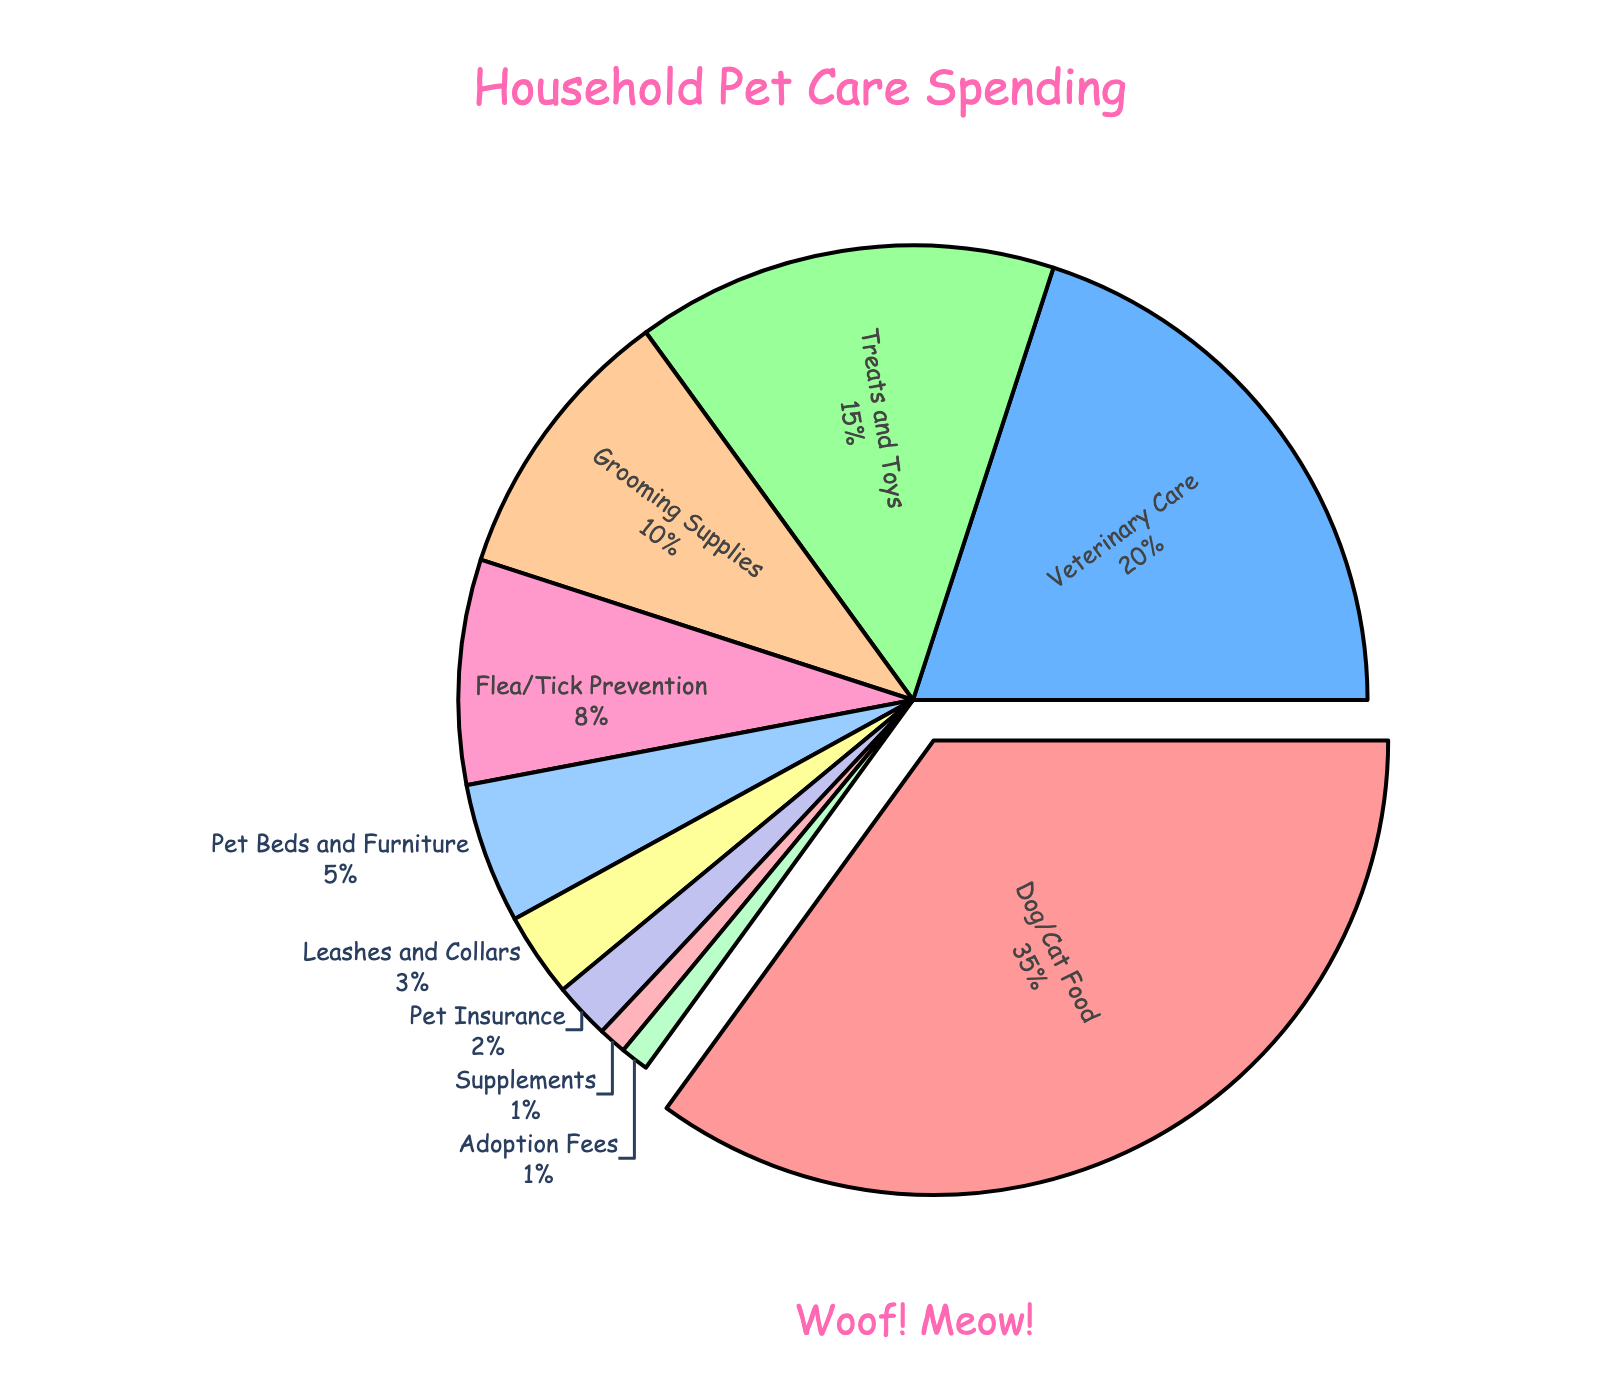Who is the largest portion of household spending on pet care and supplies? The largest portion of household spending is indicated by the slice that is pulled out and has the largest percentage. This category is "Dog/Cat Food," which makes up 35% of the spending.
Answer: Dog/Cat Food Which category is the smallest portion of household spending? The smallest portion is represented by the smallest slice of the pie chart. In this case, "Supplements" and "Adoption Fees" are tied for the smallest portion, each making up 1%.
Answer: Supplements and Adoption Fees How much more is spent on "Veterinary Care" compared to "Grooming Supplies"? First, find the percentages for "Veterinary Care" and "Grooming Supplies" which are 20% and 10%, respectively. Then, subtract the percentage for "Grooming Supplies" from "Veterinary Care" (20% - 10% = 10%).
Answer: 10% Which two categories combined are just under half of the household pet care spending? To find which categories combined make up just under half, look for two categories whose percentages sum up to just under 50%. "Dog/Cat Food" at 35% and "Veterinary Care" at 20% together make 55%, which is over half. "Dog/Cat Food" at 35% and "Treats and Toys" at 15% sum up to 50%, which is exactly half. Hence, there is no perfect pair just under 50%. The closest pairs without going over are "Dog/Cat Food" (35%) and "Treats and Toys" (15%) which exactly add up to 50%.
Answer: Dog/Cat Food and Treats and Toys Which category has a larger portion of spending: "Flea/Tick Prevention" or "Pet Beds and Furniture"? Compare the percentages of the two categories. "Flea/Tick Prevention" has 8% while "Pet Beds and Furniture" has 5%. Therefore, "Flea/Tick Prevention" has a larger portion of spending.
Answer: Flea/Tick Prevention What is the total percentage of spending for categories related to pet health (Veterinary Care, Flea/Tick Prevention, Supplements)? Sum the percentages of "Veterinary Care" (20%), "Flea/Tick Prevention" (8%), and "Supplements" (1%). The total is 20% + 8% + 1% = 29%.
Answer: 29% How many categories have spending percentages that are less than 5%? Identify the categories with percentages less than 5%. These are "Leashes and Collars" (3%), "Pet Insurance" (2%), "Supplements" (1%), and "Adoption Fees" (1%). Count the categories: there are 4 such categories.
Answer: 4 What is the combined spending percentage for "Grooming Supplies" and "Treats and Toys"? Add the percentages for "Grooming Supplies" (10%) and "Treats and Toys" (15%). The combined percentage is 10% + 15% = 25%.
Answer: 25% If the spending on "Pet Insurance" doubled, what would be the new percentage? Doubling the percentage for "Pet Insurance" means multiplying the current percentage by 2. The current percentage is 2%, so the new percentage would be 2% * 2 = 4%.
Answer: 4% Is the spending on "Pet Beds and Furniture" greater than the sum of "Supplements" and "Adoption Fees"? Compare the percentage of "Pet Beds and Furniture" (5%) with the sum of "Supplements" (1%) and "Adoption Fees" (1%). The sum is 1% + 1% = 2%, which is less than 5%. Hence, the spending on "Pet Beds and Furniture" is greater.
Answer: Yes 